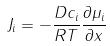<formula> <loc_0><loc_0><loc_500><loc_500>J _ { i } = - \frac { D c _ { i } } { R T } \frac { \partial \mu _ { i } } { \partial x }</formula> 